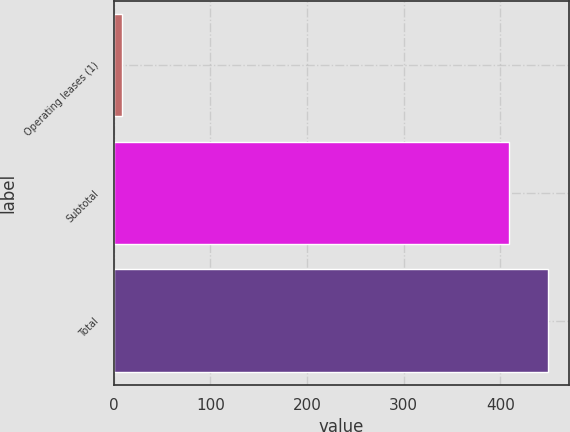Convert chart. <chart><loc_0><loc_0><loc_500><loc_500><bar_chart><fcel>Operating leases (1)<fcel>Subtotal<fcel>Total<nl><fcel>9<fcel>409<fcel>449<nl></chart> 